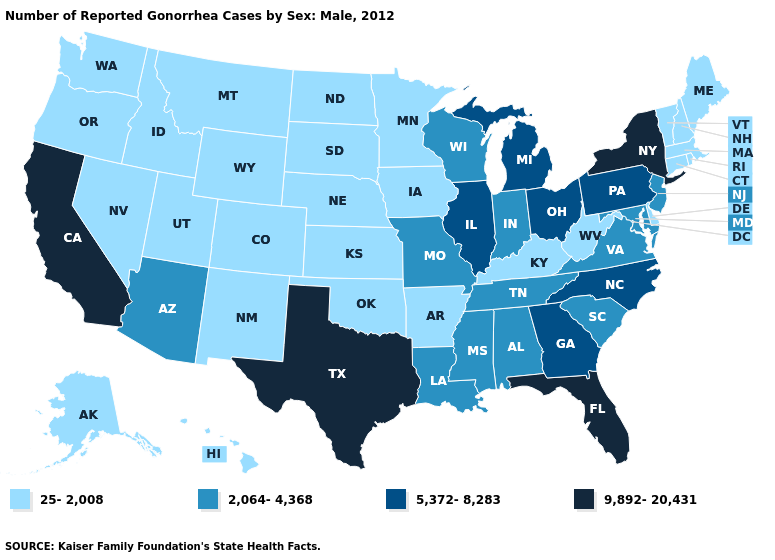What is the highest value in the USA?
Answer briefly. 9,892-20,431. What is the value of Vermont?
Short answer required. 25-2,008. Which states have the lowest value in the Northeast?
Write a very short answer. Connecticut, Maine, Massachusetts, New Hampshire, Rhode Island, Vermont. Name the states that have a value in the range 5,372-8,283?
Keep it brief. Georgia, Illinois, Michigan, North Carolina, Ohio, Pennsylvania. Name the states that have a value in the range 2,064-4,368?
Be succinct. Alabama, Arizona, Indiana, Louisiana, Maryland, Mississippi, Missouri, New Jersey, South Carolina, Tennessee, Virginia, Wisconsin. What is the value of Oklahoma?
Keep it brief. 25-2,008. Name the states that have a value in the range 25-2,008?
Write a very short answer. Alaska, Arkansas, Colorado, Connecticut, Delaware, Hawaii, Idaho, Iowa, Kansas, Kentucky, Maine, Massachusetts, Minnesota, Montana, Nebraska, Nevada, New Hampshire, New Mexico, North Dakota, Oklahoma, Oregon, Rhode Island, South Dakota, Utah, Vermont, Washington, West Virginia, Wyoming. Does New Hampshire have the highest value in the Northeast?
Concise answer only. No. Which states have the lowest value in the West?
Concise answer only. Alaska, Colorado, Hawaii, Idaho, Montana, Nevada, New Mexico, Oregon, Utah, Washington, Wyoming. What is the value of Michigan?
Give a very brief answer. 5,372-8,283. Name the states that have a value in the range 25-2,008?
Quick response, please. Alaska, Arkansas, Colorado, Connecticut, Delaware, Hawaii, Idaho, Iowa, Kansas, Kentucky, Maine, Massachusetts, Minnesota, Montana, Nebraska, Nevada, New Hampshire, New Mexico, North Dakota, Oklahoma, Oregon, Rhode Island, South Dakota, Utah, Vermont, Washington, West Virginia, Wyoming. Does the map have missing data?
Give a very brief answer. No. What is the lowest value in the Northeast?
Write a very short answer. 25-2,008. How many symbols are there in the legend?
Concise answer only. 4. 